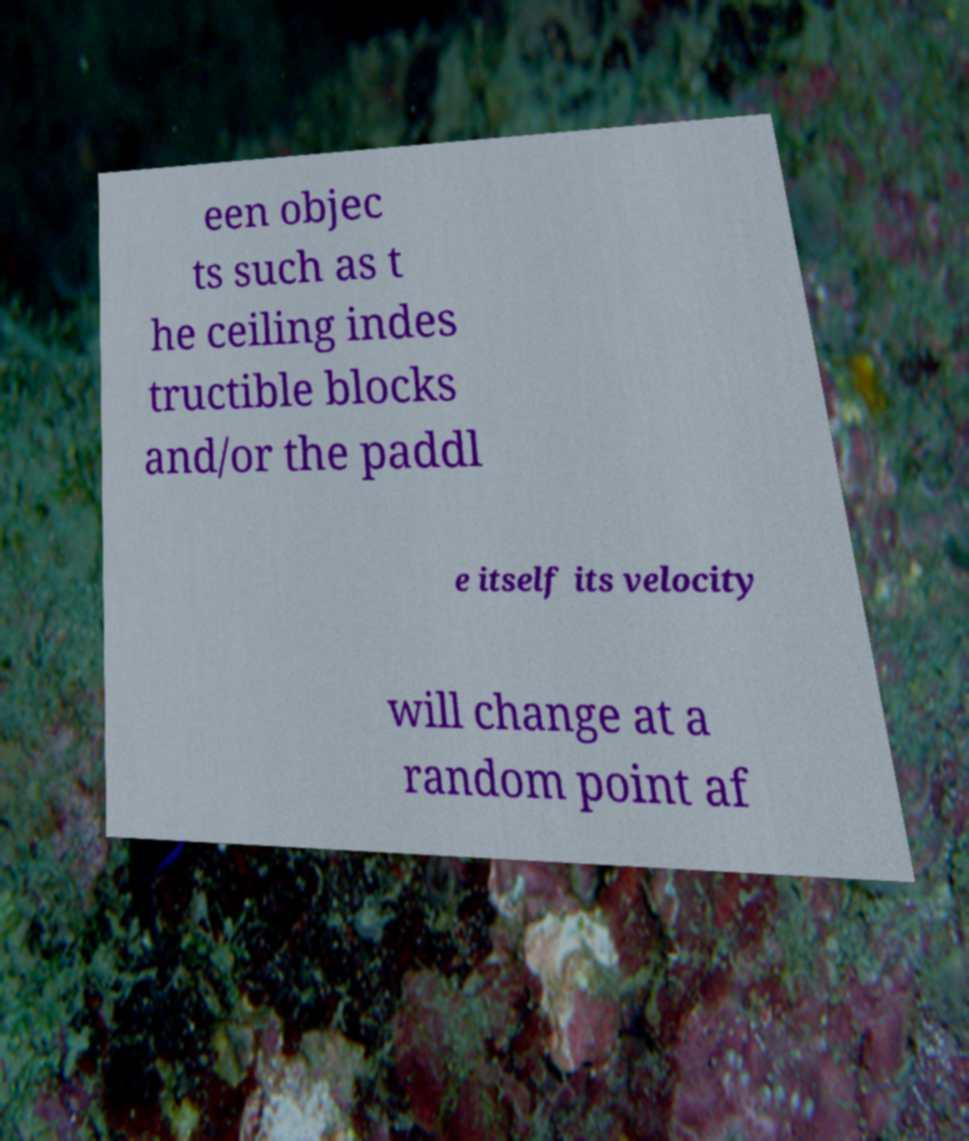Could you extract and type out the text from this image? een objec ts such as t he ceiling indes tructible blocks and/or the paddl e itself its velocity will change at a random point af 